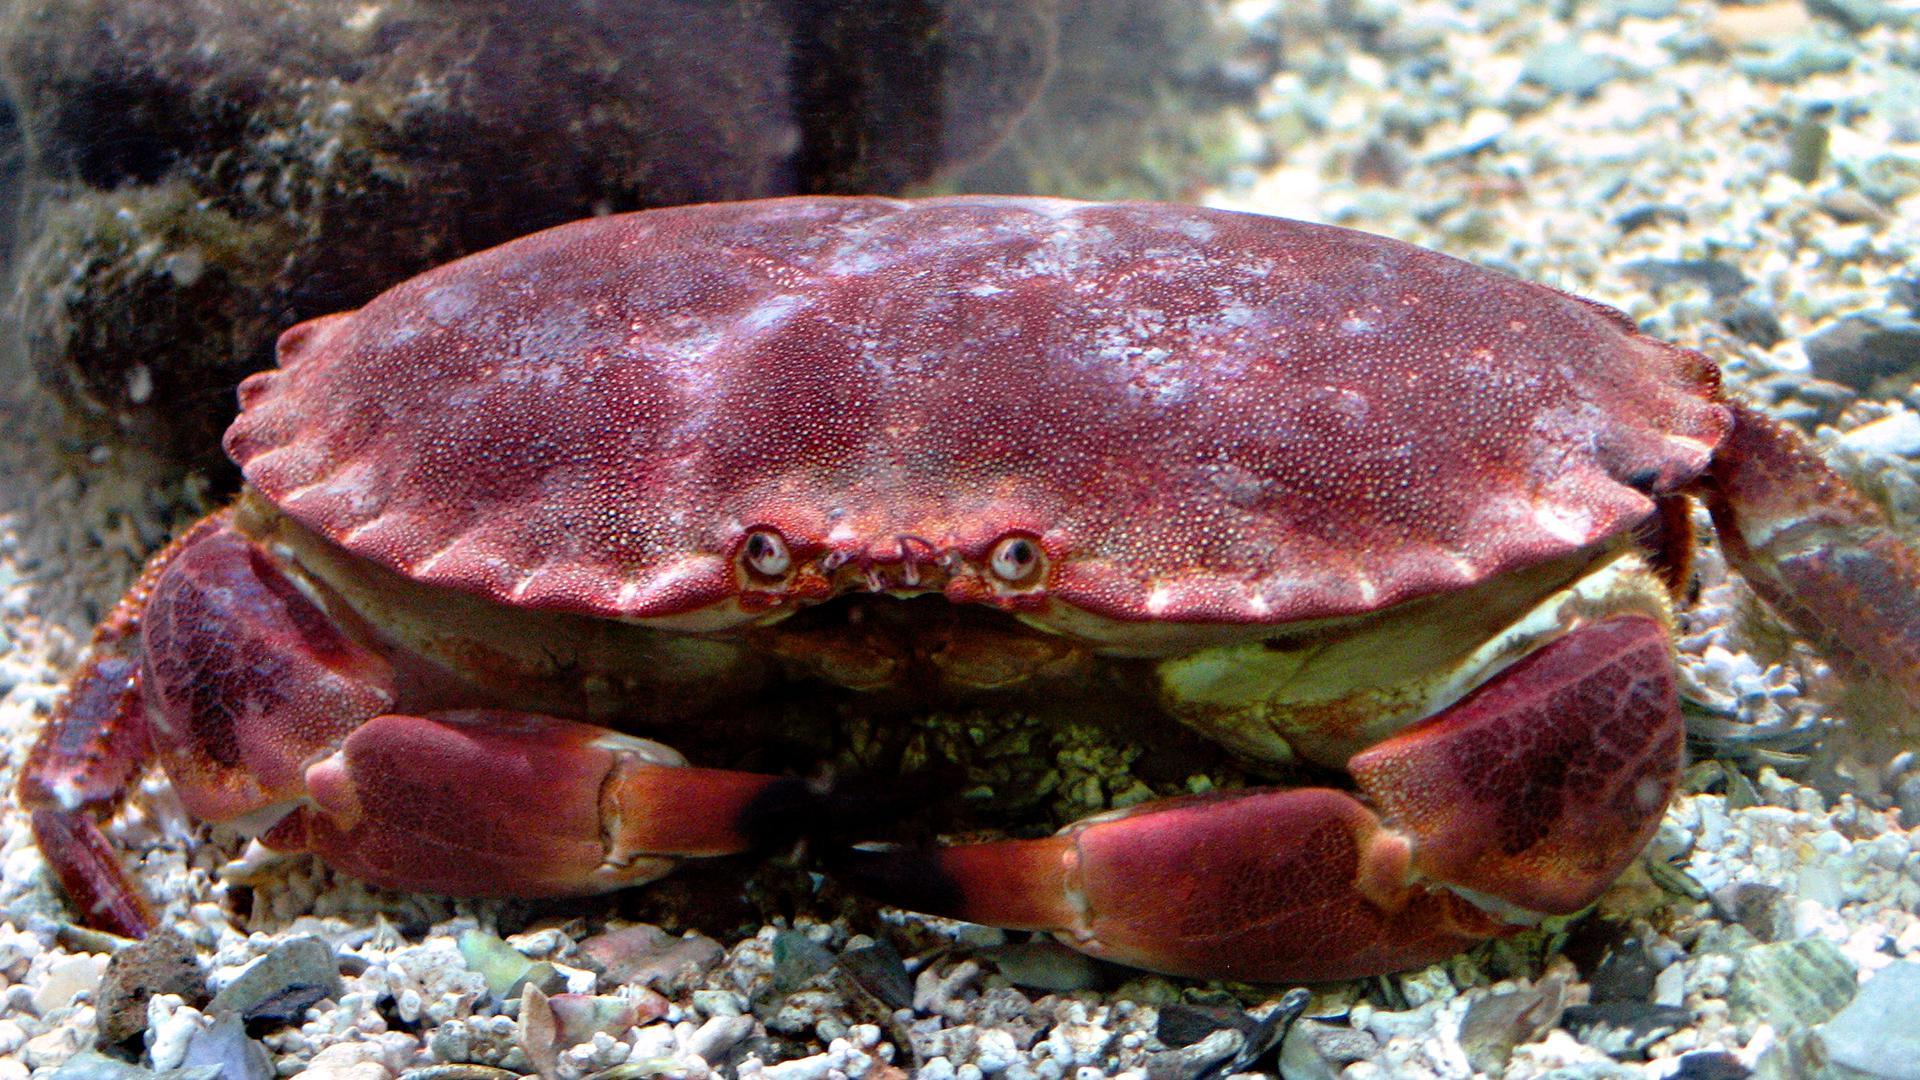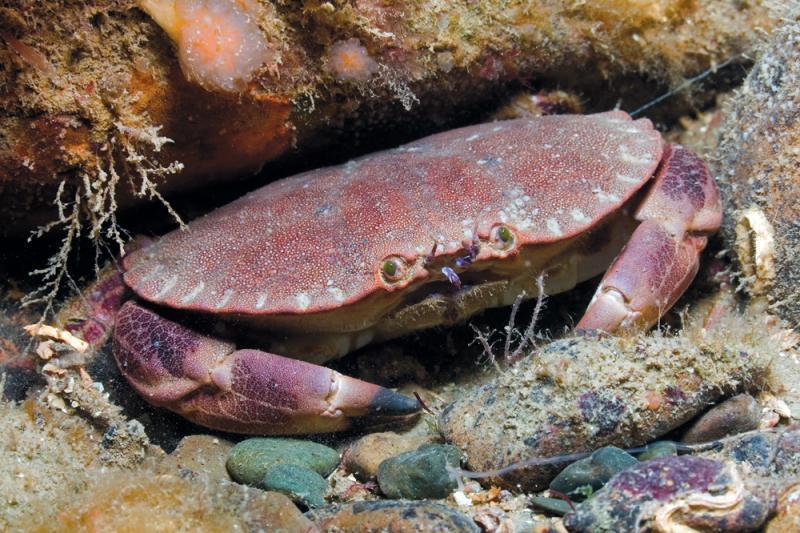The first image is the image on the left, the second image is the image on the right. Examine the images to the left and right. Is the description "Each image shows one purple crab with dark-tipped front claws that is facing the camera." accurate? Answer yes or no. Yes. The first image is the image on the left, the second image is the image on the right. Analyze the images presented: Is the assertion "The tips of every crab's claws are noticeably black." valid? Answer yes or no. Yes. 